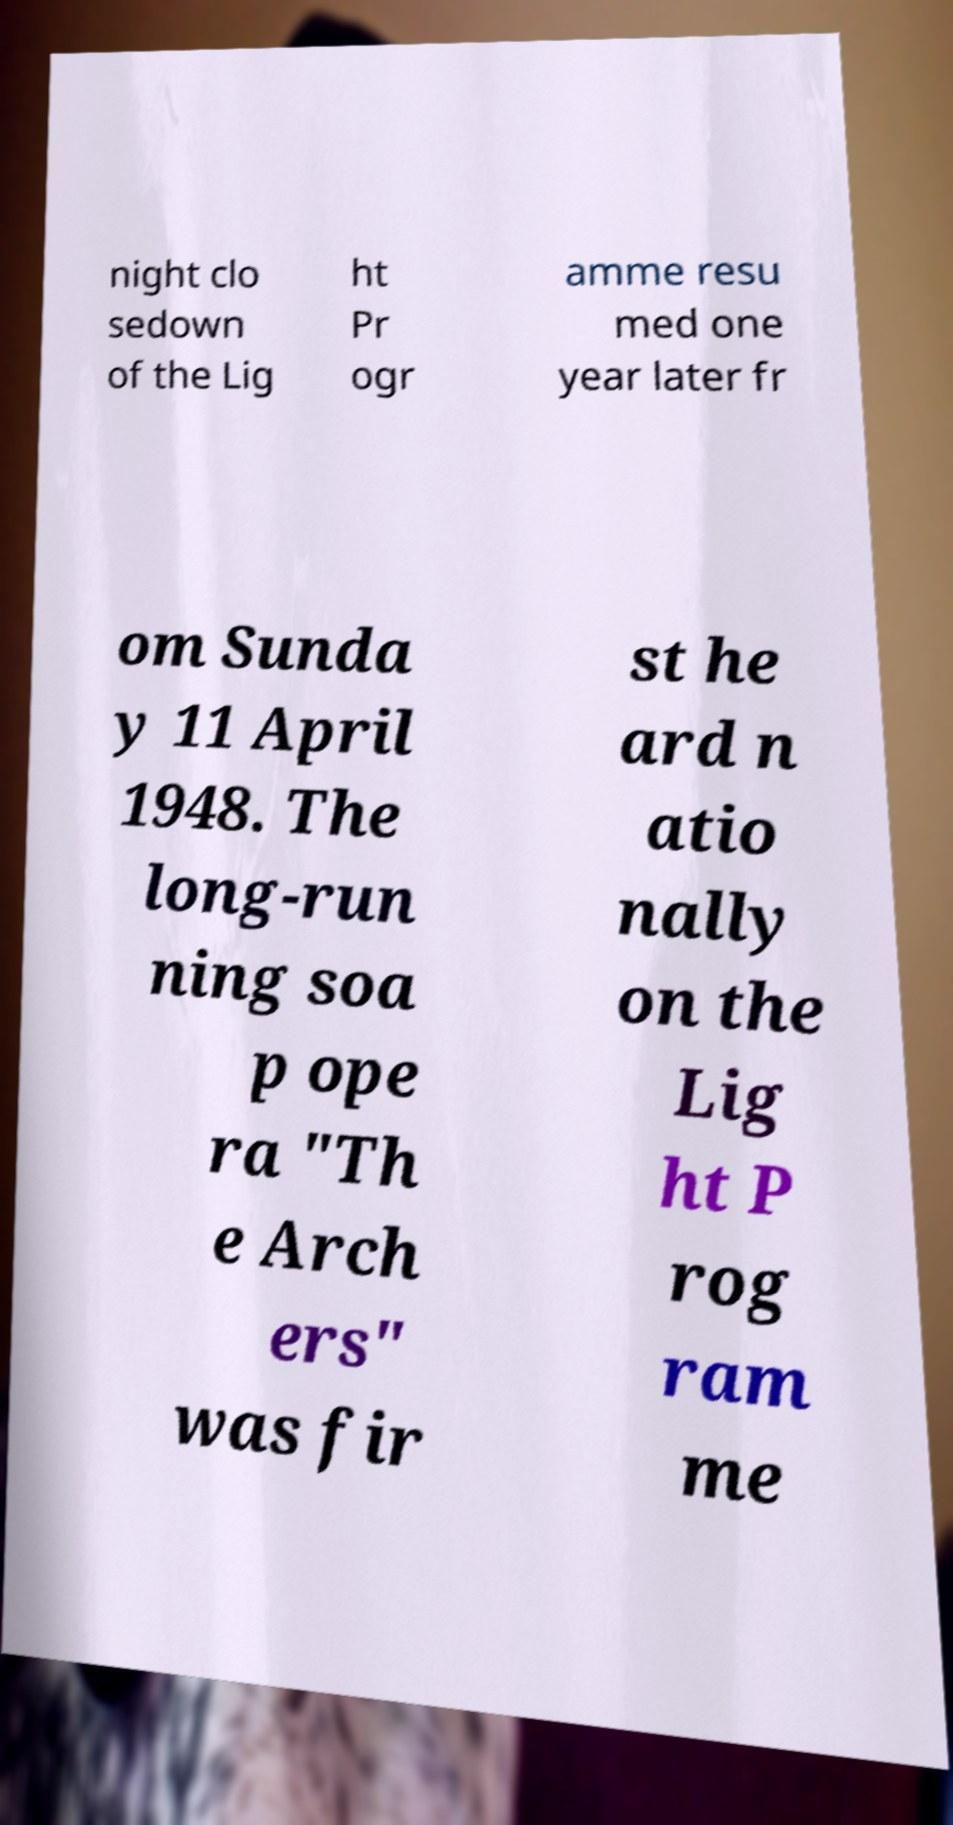Please identify and transcribe the text found in this image. night clo sedown of the Lig ht Pr ogr amme resu med one year later fr om Sunda y 11 April 1948. The long-run ning soa p ope ra "Th e Arch ers" was fir st he ard n atio nally on the Lig ht P rog ram me 